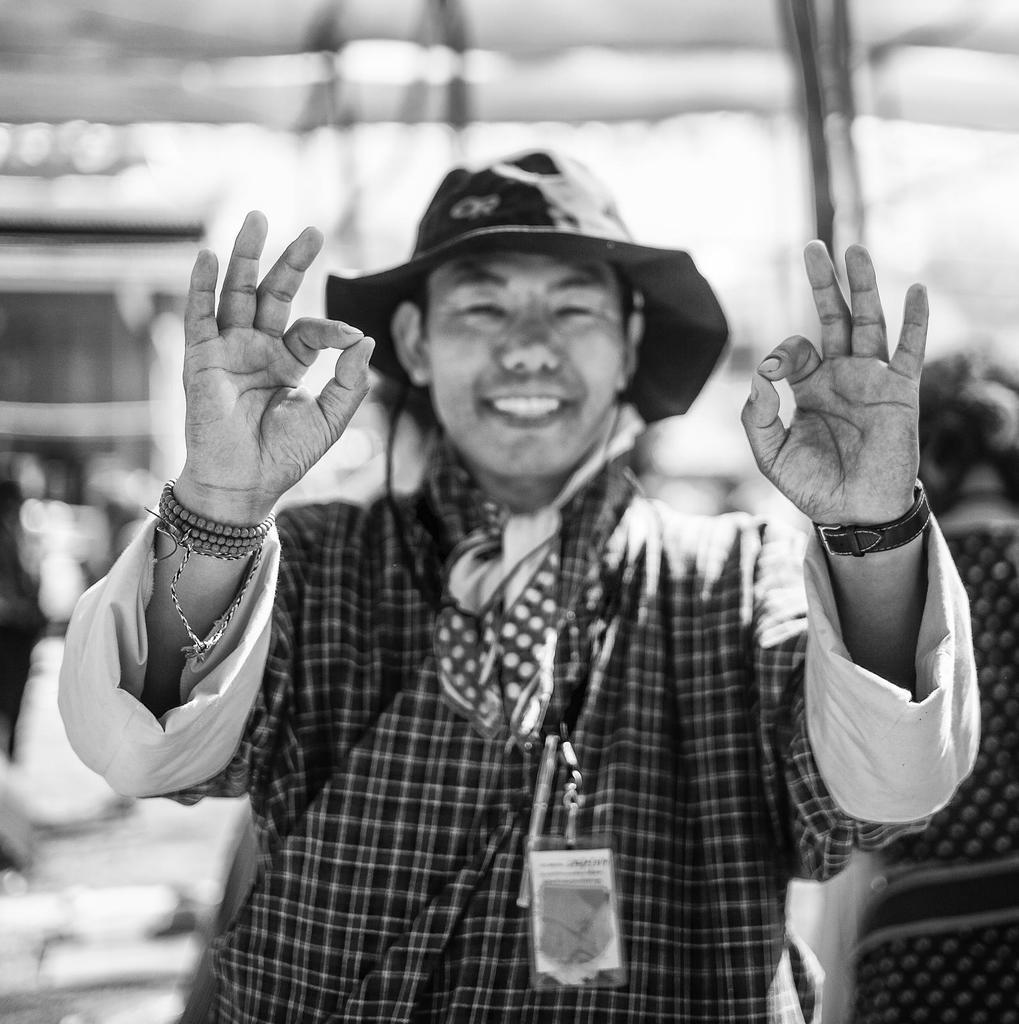Can you describe this image briefly? This is a black and white image. In this image there is a person standing on the road wearing a hat. In the background we can see building and persons. 